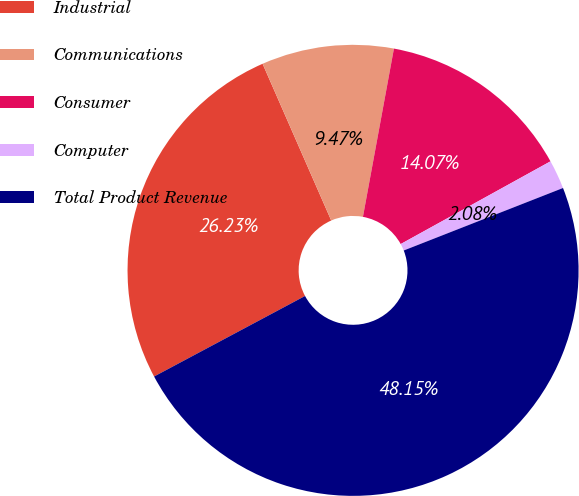Convert chart. <chart><loc_0><loc_0><loc_500><loc_500><pie_chart><fcel>Industrial<fcel>Communications<fcel>Consumer<fcel>Computer<fcel>Total Product Revenue<nl><fcel>26.23%<fcel>9.47%<fcel>14.07%<fcel>2.08%<fcel>48.15%<nl></chart> 